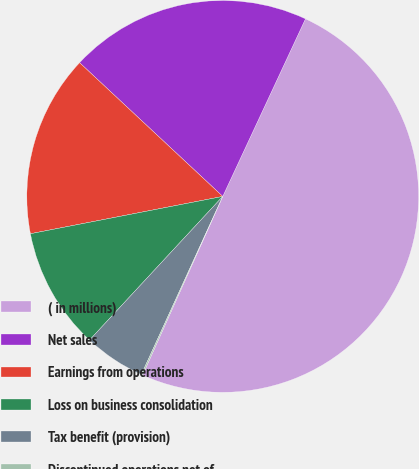<chart> <loc_0><loc_0><loc_500><loc_500><pie_chart><fcel>( in millions)<fcel>Net sales<fcel>Earnings from operations<fcel>Loss on business consolidation<fcel>Tax benefit (provision)<fcel>Discontinued operations net of<nl><fcel>49.77%<fcel>19.98%<fcel>15.01%<fcel>10.05%<fcel>5.08%<fcel>0.11%<nl></chart> 